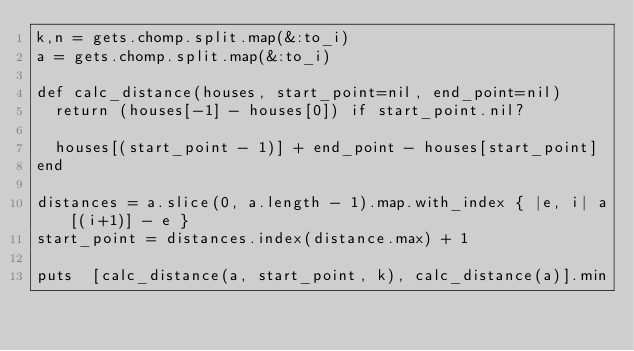<code> <loc_0><loc_0><loc_500><loc_500><_Ruby_>k,n = gets.chomp.split.map(&:to_i)
a = gets.chomp.split.map(&:to_i)

def calc_distance(houses, start_point=nil, end_point=nil)
  return (houses[-1] - houses[0]) if start_point.nil?

  houses[(start_point - 1)] + end_point - houses[start_point]
end

distances = a.slice(0, a.length - 1).map.with_index { |e, i| a[(i+1)] - e }
start_point = distances.index(distance.max) + 1

puts  [calc_distance(a, start_point, k), calc_distance(a)].min</code> 